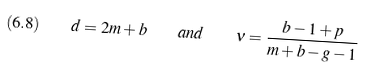<formula> <loc_0><loc_0><loc_500><loc_500>( 6 . 8 ) \quad d = 2 m + b \quad a n d \quad \nu = \frac { b - 1 + p } { m + b - g - 1 }</formula> 